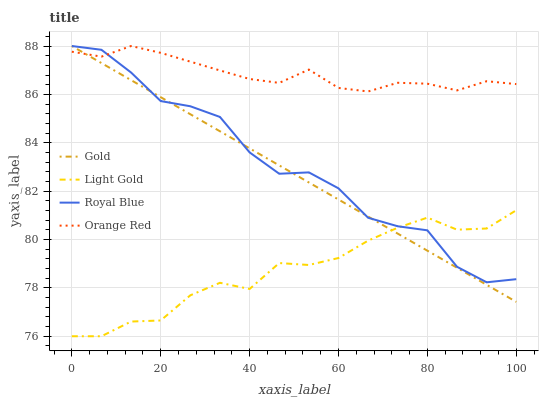Does Light Gold have the minimum area under the curve?
Answer yes or no. Yes. Does Orange Red have the maximum area under the curve?
Answer yes or no. Yes. Does Orange Red have the minimum area under the curve?
Answer yes or no. No. Does Light Gold have the maximum area under the curve?
Answer yes or no. No. Is Gold the smoothest?
Answer yes or no. Yes. Is Royal Blue the roughest?
Answer yes or no. Yes. Is Light Gold the smoothest?
Answer yes or no. No. Is Light Gold the roughest?
Answer yes or no. No. Does Light Gold have the lowest value?
Answer yes or no. Yes. Does Orange Red have the lowest value?
Answer yes or no. No. Does Gold have the highest value?
Answer yes or no. Yes. Does Light Gold have the highest value?
Answer yes or no. No. Is Light Gold less than Orange Red?
Answer yes or no. Yes. Is Orange Red greater than Light Gold?
Answer yes or no. Yes. Does Royal Blue intersect Light Gold?
Answer yes or no. Yes. Is Royal Blue less than Light Gold?
Answer yes or no. No. Is Royal Blue greater than Light Gold?
Answer yes or no. No. Does Light Gold intersect Orange Red?
Answer yes or no. No. 